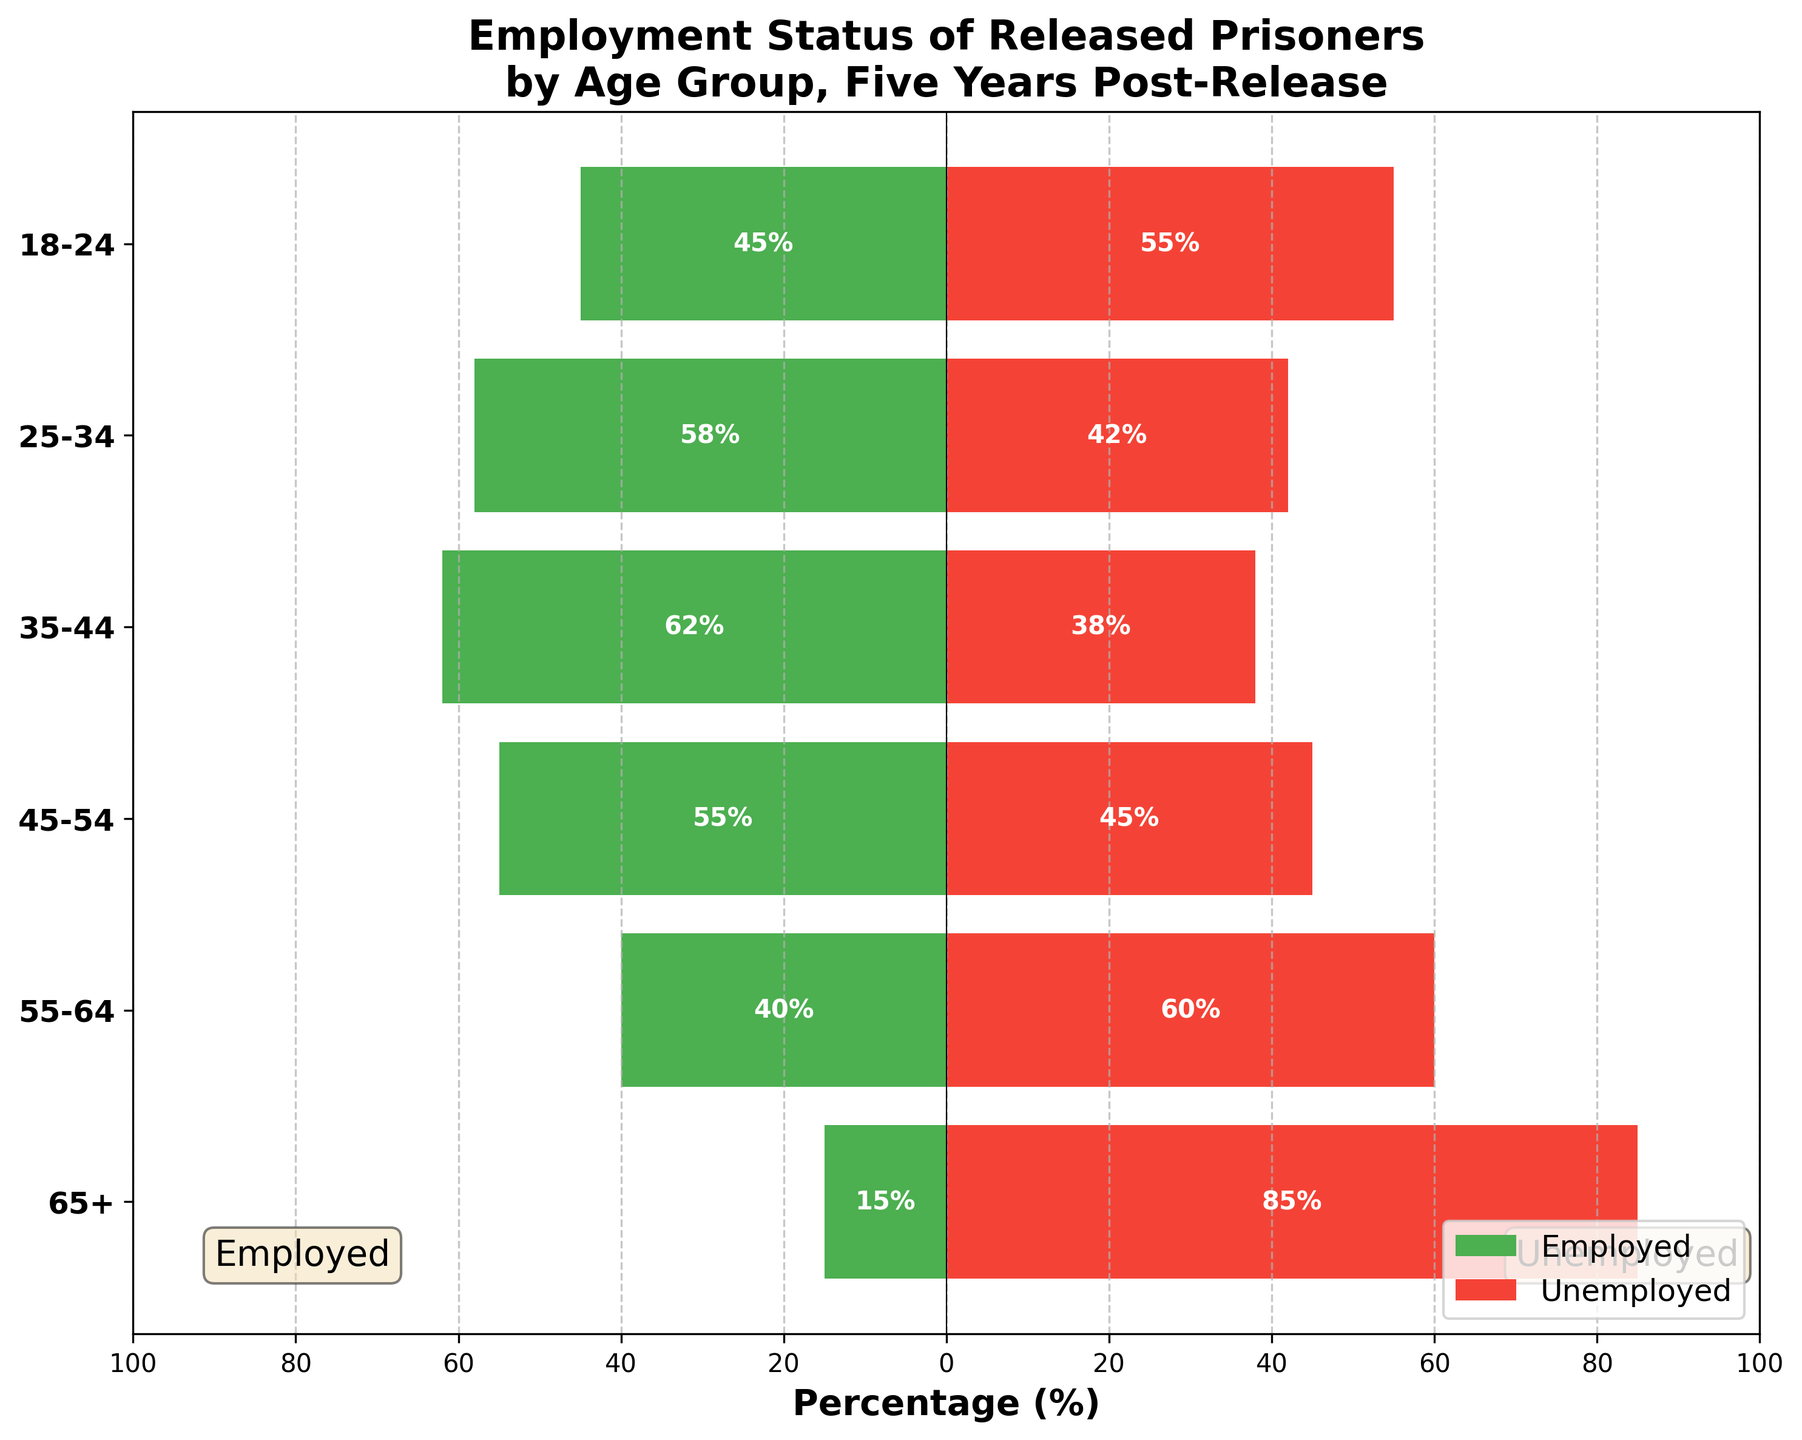What is the title of the figure? The title is located at the top of the figure and provides a brief description of the content of the chart.
Answer: Employment Status of Released Prisoners by Age Group, Five Years Post-Release How does the employment status of prisoners aged 25-34 compare to those aged 18-24? By observing the two age groups, the 25-34 group has a higher employment percentage (58%) compared to the 18-24 group (45%).
Answer: 25-34 group has higher employment Which age group has the highest unemployment rate? By examining the percentages on the right side of the chart, the age group with the highest unemployment rate is the 65+ group, listed at 85%.
Answer: 65+ age group What is the employment percentage for the 35-44 age group? The figure shows green bars representing employment percentages. For the 35-44 age group, the bar indicates a value of 62%.
Answer: 62% What is the difference in employment rates between the 45-54 and 55-64 age groups? The employment rates are 55% for the 45-54 age group and 40% for the 55-64 age group. Subtracting these gives 15%.
Answer: 15% Which age group has the most balanced employment/unemployment rates? The most balanced rates are seen in the 45-54 age group, where employment is 55% and unemployment is 45%, leading to a relatively balanced distribution.
Answer: 45-54 age group How do the unemployment rates for the 35-44 and 45-54 age groups differ? The unemployment rates are 38% for the 35-44 group and 45% for the 45-54 group. The difference is 7%.
Answer: 7% What is the average employment percentage across all age groups? Sum the employment percentages (45+58+62+55+40+15) = 275. There are 6 groups, so the average is 275/6 ≈ 45.83%.
Answer: 45.83% Between which age groups does the employment rate drop significantly? Observing the employment rates, the significant drop occurs between the 45-54 age group (55%) and the 55-64 age group (40%).
Answer: Between 45-54 and 55-64 What can be inferred from the employment and unemployment bars for the 65+ age group? The 65+ age group shows the lowest employment at 15% and the highest unemployment at 85%, indicating significant reintegration issues for older released prisoners.
Answer: Employment is very low, and unemployment is very high 